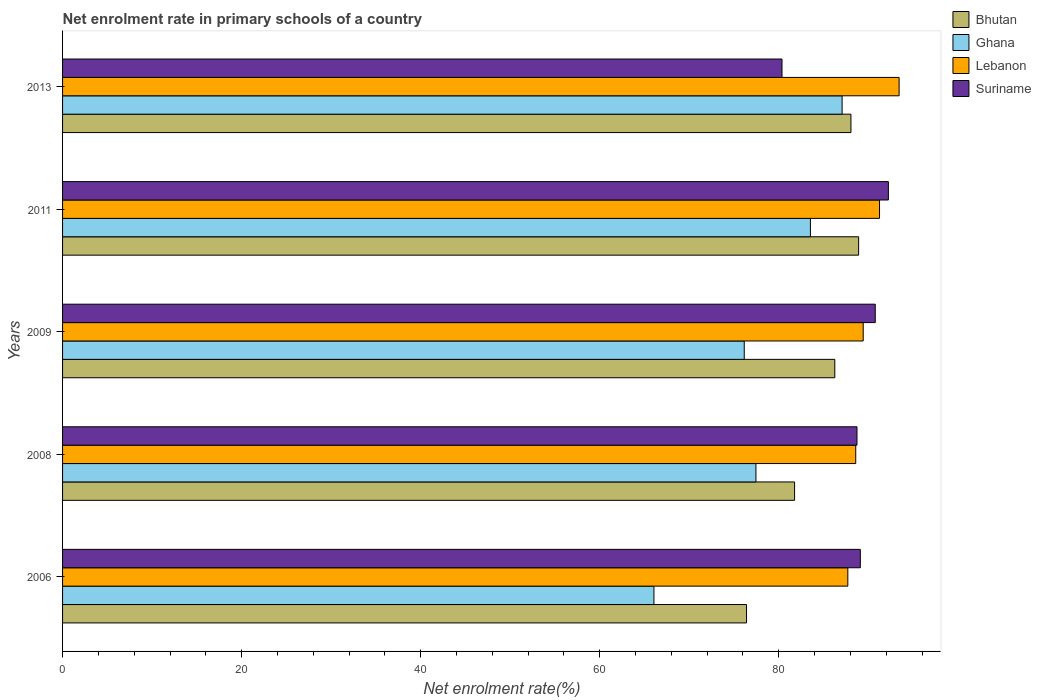How many groups of bars are there?
Give a very brief answer. 5. How many bars are there on the 4th tick from the top?
Your answer should be very brief. 4. How many bars are there on the 5th tick from the bottom?
Give a very brief answer. 4. What is the label of the 3rd group of bars from the top?
Provide a short and direct response. 2009. What is the net enrolment rate in primary schools in Bhutan in 2008?
Your answer should be compact. 81.77. Across all years, what is the maximum net enrolment rate in primary schools in Suriname?
Provide a succinct answer. 92.24. Across all years, what is the minimum net enrolment rate in primary schools in Suriname?
Keep it short and to the point. 80.36. In which year was the net enrolment rate in primary schools in Ghana maximum?
Your answer should be very brief. 2013. In which year was the net enrolment rate in primary schools in Lebanon minimum?
Your answer should be compact. 2006. What is the total net enrolment rate in primary schools in Ghana in the graph?
Your answer should be compact. 390.26. What is the difference between the net enrolment rate in primary schools in Lebanon in 2009 and that in 2011?
Ensure brevity in your answer.  -1.82. What is the difference between the net enrolment rate in primary schools in Bhutan in 2008 and the net enrolment rate in primary schools in Ghana in 2013?
Give a very brief answer. -5.31. What is the average net enrolment rate in primary schools in Lebanon per year?
Provide a succinct answer. 90.09. In the year 2008, what is the difference between the net enrolment rate in primary schools in Lebanon and net enrolment rate in primary schools in Suriname?
Offer a terse response. -0.14. In how many years, is the net enrolment rate in primary schools in Ghana greater than 76 %?
Offer a very short reply. 4. What is the ratio of the net enrolment rate in primary schools in Lebanon in 2008 to that in 2013?
Give a very brief answer. 0.95. Is the net enrolment rate in primary schools in Suriname in 2006 less than that in 2011?
Ensure brevity in your answer.  Yes. What is the difference between the highest and the second highest net enrolment rate in primary schools in Lebanon?
Give a very brief answer. 2.19. What is the difference between the highest and the lowest net enrolment rate in primary schools in Lebanon?
Keep it short and to the point. 5.73. In how many years, is the net enrolment rate in primary schools in Bhutan greater than the average net enrolment rate in primary schools in Bhutan taken over all years?
Your response must be concise. 3. Is it the case that in every year, the sum of the net enrolment rate in primary schools in Suriname and net enrolment rate in primary schools in Lebanon is greater than the sum of net enrolment rate in primary schools in Ghana and net enrolment rate in primary schools in Bhutan?
Your answer should be compact. Yes. What does the 1st bar from the top in 2006 represents?
Make the answer very short. Suriname. What does the 2nd bar from the bottom in 2011 represents?
Provide a succinct answer. Ghana. Is it the case that in every year, the sum of the net enrolment rate in primary schools in Suriname and net enrolment rate in primary schools in Ghana is greater than the net enrolment rate in primary schools in Bhutan?
Your answer should be compact. Yes. How many bars are there?
Your answer should be compact. 20. How many years are there in the graph?
Your answer should be very brief. 5. What is the difference between two consecutive major ticks on the X-axis?
Keep it short and to the point. 20. Does the graph contain any zero values?
Keep it short and to the point. No. Does the graph contain grids?
Offer a very short reply. No. Where does the legend appear in the graph?
Provide a short and direct response. Top right. How are the legend labels stacked?
Give a very brief answer. Vertical. What is the title of the graph?
Your answer should be compact. Net enrolment rate in primary schools of a country. What is the label or title of the X-axis?
Make the answer very short. Net enrolment rate(%). What is the Net enrolment rate(%) in Bhutan in 2006?
Offer a very short reply. 76.4. What is the Net enrolment rate(%) of Ghana in 2006?
Your answer should be very brief. 66.06. What is the Net enrolment rate(%) of Lebanon in 2006?
Give a very brief answer. 87.71. What is the Net enrolment rate(%) in Suriname in 2006?
Your answer should be very brief. 89.11. What is the Net enrolment rate(%) in Bhutan in 2008?
Give a very brief answer. 81.77. What is the Net enrolment rate(%) in Ghana in 2008?
Keep it short and to the point. 77.45. What is the Net enrolment rate(%) in Lebanon in 2008?
Provide a short and direct response. 88.6. What is the Net enrolment rate(%) of Suriname in 2008?
Your answer should be compact. 88.74. What is the Net enrolment rate(%) in Bhutan in 2009?
Keep it short and to the point. 86.26. What is the Net enrolment rate(%) in Ghana in 2009?
Keep it short and to the point. 76.14. What is the Net enrolment rate(%) of Lebanon in 2009?
Give a very brief answer. 89.43. What is the Net enrolment rate(%) of Suriname in 2009?
Give a very brief answer. 90.78. What is the Net enrolment rate(%) of Bhutan in 2011?
Your answer should be compact. 88.92. What is the Net enrolment rate(%) in Ghana in 2011?
Provide a succinct answer. 83.54. What is the Net enrolment rate(%) of Lebanon in 2011?
Offer a very short reply. 91.26. What is the Net enrolment rate(%) in Suriname in 2011?
Provide a succinct answer. 92.24. What is the Net enrolment rate(%) in Bhutan in 2013?
Provide a short and direct response. 88.06. What is the Net enrolment rate(%) of Ghana in 2013?
Provide a succinct answer. 87.07. What is the Net enrolment rate(%) in Lebanon in 2013?
Ensure brevity in your answer.  93.44. What is the Net enrolment rate(%) of Suriname in 2013?
Provide a short and direct response. 80.36. Across all years, what is the maximum Net enrolment rate(%) in Bhutan?
Make the answer very short. 88.92. Across all years, what is the maximum Net enrolment rate(%) of Ghana?
Provide a short and direct response. 87.07. Across all years, what is the maximum Net enrolment rate(%) of Lebanon?
Offer a very short reply. 93.44. Across all years, what is the maximum Net enrolment rate(%) in Suriname?
Give a very brief answer. 92.24. Across all years, what is the minimum Net enrolment rate(%) of Bhutan?
Give a very brief answer. 76.4. Across all years, what is the minimum Net enrolment rate(%) of Ghana?
Keep it short and to the point. 66.06. Across all years, what is the minimum Net enrolment rate(%) of Lebanon?
Offer a very short reply. 87.71. Across all years, what is the minimum Net enrolment rate(%) of Suriname?
Your answer should be very brief. 80.36. What is the total Net enrolment rate(%) of Bhutan in the graph?
Your response must be concise. 421.4. What is the total Net enrolment rate(%) of Ghana in the graph?
Your answer should be very brief. 390.26. What is the total Net enrolment rate(%) of Lebanon in the graph?
Your response must be concise. 450.44. What is the total Net enrolment rate(%) in Suriname in the graph?
Your answer should be compact. 441.23. What is the difference between the Net enrolment rate(%) of Bhutan in 2006 and that in 2008?
Offer a terse response. -5.37. What is the difference between the Net enrolment rate(%) of Ghana in 2006 and that in 2008?
Offer a terse response. -11.39. What is the difference between the Net enrolment rate(%) of Lebanon in 2006 and that in 2008?
Keep it short and to the point. -0.88. What is the difference between the Net enrolment rate(%) in Suriname in 2006 and that in 2008?
Provide a short and direct response. 0.37. What is the difference between the Net enrolment rate(%) of Bhutan in 2006 and that in 2009?
Your response must be concise. -9.86. What is the difference between the Net enrolment rate(%) of Ghana in 2006 and that in 2009?
Ensure brevity in your answer.  -10.09. What is the difference between the Net enrolment rate(%) of Lebanon in 2006 and that in 2009?
Your response must be concise. -1.72. What is the difference between the Net enrolment rate(%) of Suriname in 2006 and that in 2009?
Provide a succinct answer. -1.67. What is the difference between the Net enrolment rate(%) of Bhutan in 2006 and that in 2011?
Your response must be concise. -12.52. What is the difference between the Net enrolment rate(%) in Ghana in 2006 and that in 2011?
Provide a succinct answer. -17.48. What is the difference between the Net enrolment rate(%) of Lebanon in 2006 and that in 2011?
Offer a terse response. -3.54. What is the difference between the Net enrolment rate(%) in Suriname in 2006 and that in 2011?
Provide a succinct answer. -3.13. What is the difference between the Net enrolment rate(%) in Bhutan in 2006 and that in 2013?
Ensure brevity in your answer.  -11.66. What is the difference between the Net enrolment rate(%) in Ghana in 2006 and that in 2013?
Ensure brevity in your answer.  -21.02. What is the difference between the Net enrolment rate(%) in Lebanon in 2006 and that in 2013?
Make the answer very short. -5.73. What is the difference between the Net enrolment rate(%) of Suriname in 2006 and that in 2013?
Provide a short and direct response. 8.75. What is the difference between the Net enrolment rate(%) of Bhutan in 2008 and that in 2009?
Your answer should be compact. -4.49. What is the difference between the Net enrolment rate(%) of Ghana in 2008 and that in 2009?
Keep it short and to the point. 1.31. What is the difference between the Net enrolment rate(%) in Lebanon in 2008 and that in 2009?
Provide a short and direct response. -0.83. What is the difference between the Net enrolment rate(%) of Suriname in 2008 and that in 2009?
Your response must be concise. -2.04. What is the difference between the Net enrolment rate(%) in Bhutan in 2008 and that in 2011?
Your answer should be compact. -7.15. What is the difference between the Net enrolment rate(%) in Ghana in 2008 and that in 2011?
Your answer should be compact. -6.08. What is the difference between the Net enrolment rate(%) in Lebanon in 2008 and that in 2011?
Keep it short and to the point. -2.66. What is the difference between the Net enrolment rate(%) in Suriname in 2008 and that in 2011?
Your answer should be compact. -3.51. What is the difference between the Net enrolment rate(%) of Bhutan in 2008 and that in 2013?
Offer a very short reply. -6.29. What is the difference between the Net enrolment rate(%) of Ghana in 2008 and that in 2013?
Your response must be concise. -9.62. What is the difference between the Net enrolment rate(%) in Lebanon in 2008 and that in 2013?
Your answer should be compact. -4.84. What is the difference between the Net enrolment rate(%) of Suriname in 2008 and that in 2013?
Make the answer very short. 8.38. What is the difference between the Net enrolment rate(%) of Bhutan in 2009 and that in 2011?
Your answer should be very brief. -2.66. What is the difference between the Net enrolment rate(%) in Ghana in 2009 and that in 2011?
Your answer should be very brief. -7.39. What is the difference between the Net enrolment rate(%) in Lebanon in 2009 and that in 2011?
Your answer should be compact. -1.82. What is the difference between the Net enrolment rate(%) of Suriname in 2009 and that in 2011?
Offer a terse response. -1.47. What is the difference between the Net enrolment rate(%) of Bhutan in 2009 and that in 2013?
Make the answer very short. -1.8. What is the difference between the Net enrolment rate(%) of Ghana in 2009 and that in 2013?
Offer a very short reply. -10.93. What is the difference between the Net enrolment rate(%) of Lebanon in 2009 and that in 2013?
Give a very brief answer. -4.01. What is the difference between the Net enrolment rate(%) of Suriname in 2009 and that in 2013?
Your answer should be very brief. 10.42. What is the difference between the Net enrolment rate(%) of Bhutan in 2011 and that in 2013?
Your answer should be compact. 0.86. What is the difference between the Net enrolment rate(%) in Ghana in 2011 and that in 2013?
Offer a terse response. -3.54. What is the difference between the Net enrolment rate(%) of Lebanon in 2011 and that in 2013?
Give a very brief answer. -2.19. What is the difference between the Net enrolment rate(%) of Suriname in 2011 and that in 2013?
Make the answer very short. 11.88. What is the difference between the Net enrolment rate(%) in Bhutan in 2006 and the Net enrolment rate(%) in Ghana in 2008?
Offer a very short reply. -1.05. What is the difference between the Net enrolment rate(%) of Bhutan in 2006 and the Net enrolment rate(%) of Lebanon in 2008?
Your answer should be compact. -12.2. What is the difference between the Net enrolment rate(%) in Bhutan in 2006 and the Net enrolment rate(%) in Suriname in 2008?
Keep it short and to the point. -12.34. What is the difference between the Net enrolment rate(%) of Ghana in 2006 and the Net enrolment rate(%) of Lebanon in 2008?
Keep it short and to the point. -22.54. What is the difference between the Net enrolment rate(%) in Ghana in 2006 and the Net enrolment rate(%) in Suriname in 2008?
Ensure brevity in your answer.  -22.68. What is the difference between the Net enrolment rate(%) of Lebanon in 2006 and the Net enrolment rate(%) of Suriname in 2008?
Provide a succinct answer. -1.02. What is the difference between the Net enrolment rate(%) in Bhutan in 2006 and the Net enrolment rate(%) in Ghana in 2009?
Offer a very short reply. 0.25. What is the difference between the Net enrolment rate(%) of Bhutan in 2006 and the Net enrolment rate(%) of Lebanon in 2009?
Your response must be concise. -13.03. What is the difference between the Net enrolment rate(%) of Bhutan in 2006 and the Net enrolment rate(%) of Suriname in 2009?
Ensure brevity in your answer.  -14.38. What is the difference between the Net enrolment rate(%) of Ghana in 2006 and the Net enrolment rate(%) of Lebanon in 2009?
Your answer should be compact. -23.38. What is the difference between the Net enrolment rate(%) of Ghana in 2006 and the Net enrolment rate(%) of Suriname in 2009?
Keep it short and to the point. -24.72. What is the difference between the Net enrolment rate(%) in Lebanon in 2006 and the Net enrolment rate(%) in Suriname in 2009?
Your answer should be very brief. -3.06. What is the difference between the Net enrolment rate(%) of Bhutan in 2006 and the Net enrolment rate(%) of Ghana in 2011?
Your answer should be compact. -7.14. What is the difference between the Net enrolment rate(%) of Bhutan in 2006 and the Net enrolment rate(%) of Lebanon in 2011?
Keep it short and to the point. -14.86. What is the difference between the Net enrolment rate(%) of Bhutan in 2006 and the Net enrolment rate(%) of Suriname in 2011?
Give a very brief answer. -15.85. What is the difference between the Net enrolment rate(%) of Ghana in 2006 and the Net enrolment rate(%) of Lebanon in 2011?
Give a very brief answer. -25.2. What is the difference between the Net enrolment rate(%) of Ghana in 2006 and the Net enrolment rate(%) of Suriname in 2011?
Your response must be concise. -26.19. What is the difference between the Net enrolment rate(%) in Lebanon in 2006 and the Net enrolment rate(%) in Suriname in 2011?
Ensure brevity in your answer.  -4.53. What is the difference between the Net enrolment rate(%) of Bhutan in 2006 and the Net enrolment rate(%) of Ghana in 2013?
Your answer should be compact. -10.68. What is the difference between the Net enrolment rate(%) of Bhutan in 2006 and the Net enrolment rate(%) of Lebanon in 2013?
Give a very brief answer. -17.04. What is the difference between the Net enrolment rate(%) in Bhutan in 2006 and the Net enrolment rate(%) in Suriname in 2013?
Your answer should be very brief. -3.96. What is the difference between the Net enrolment rate(%) of Ghana in 2006 and the Net enrolment rate(%) of Lebanon in 2013?
Make the answer very short. -27.39. What is the difference between the Net enrolment rate(%) in Ghana in 2006 and the Net enrolment rate(%) in Suriname in 2013?
Give a very brief answer. -14.31. What is the difference between the Net enrolment rate(%) in Lebanon in 2006 and the Net enrolment rate(%) in Suriname in 2013?
Keep it short and to the point. 7.35. What is the difference between the Net enrolment rate(%) in Bhutan in 2008 and the Net enrolment rate(%) in Ghana in 2009?
Offer a very short reply. 5.62. What is the difference between the Net enrolment rate(%) of Bhutan in 2008 and the Net enrolment rate(%) of Lebanon in 2009?
Your response must be concise. -7.67. What is the difference between the Net enrolment rate(%) in Bhutan in 2008 and the Net enrolment rate(%) in Suriname in 2009?
Offer a very short reply. -9.01. What is the difference between the Net enrolment rate(%) of Ghana in 2008 and the Net enrolment rate(%) of Lebanon in 2009?
Provide a short and direct response. -11.98. What is the difference between the Net enrolment rate(%) of Ghana in 2008 and the Net enrolment rate(%) of Suriname in 2009?
Keep it short and to the point. -13.33. What is the difference between the Net enrolment rate(%) in Lebanon in 2008 and the Net enrolment rate(%) in Suriname in 2009?
Ensure brevity in your answer.  -2.18. What is the difference between the Net enrolment rate(%) in Bhutan in 2008 and the Net enrolment rate(%) in Ghana in 2011?
Provide a succinct answer. -1.77. What is the difference between the Net enrolment rate(%) in Bhutan in 2008 and the Net enrolment rate(%) in Lebanon in 2011?
Keep it short and to the point. -9.49. What is the difference between the Net enrolment rate(%) in Bhutan in 2008 and the Net enrolment rate(%) in Suriname in 2011?
Provide a succinct answer. -10.48. What is the difference between the Net enrolment rate(%) of Ghana in 2008 and the Net enrolment rate(%) of Lebanon in 2011?
Ensure brevity in your answer.  -13.81. What is the difference between the Net enrolment rate(%) in Ghana in 2008 and the Net enrolment rate(%) in Suriname in 2011?
Your answer should be very brief. -14.79. What is the difference between the Net enrolment rate(%) in Lebanon in 2008 and the Net enrolment rate(%) in Suriname in 2011?
Ensure brevity in your answer.  -3.65. What is the difference between the Net enrolment rate(%) of Bhutan in 2008 and the Net enrolment rate(%) of Ghana in 2013?
Offer a terse response. -5.31. What is the difference between the Net enrolment rate(%) in Bhutan in 2008 and the Net enrolment rate(%) in Lebanon in 2013?
Provide a short and direct response. -11.68. What is the difference between the Net enrolment rate(%) in Bhutan in 2008 and the Net enrolment rate(%) in Suriname in 2013?
Provide a succinct answer. 1.4. What is the difference between the Net enrolment rate(%) of Ghana in 2008 and the Net enrolment rate(%) of Lebanon in 2013?
Give a very brief answer. -15.99. What is the difference between the Net enrolment rate(%) of Ghana in 2008 and the Net enrolment rate(%) of Suriname in 2013?
Your answer should be very brief. -2.91. What is the difference between the Net enrolment rate(%) of Lebanon in 2008 and the Net enrolment rate(%) of Suriname in 2013?
Ensure brevity in your answer.  8.24. What is the difference between the Net enrolment rate(%) in Bhutan in 2009 and the Net enrolment rate(%) in Ghana in 2011?
Make the answer very short. 2.72. What is the difference between the Net enrolment rate(%) in Bhutan in 2009 and the Net enrolment rate(%) in Lebanon in 2011?
Give a very brief answer. -5. What is the difference between the Net enrolment rate(%) of Bhutan in 2009 and the Net enrolment rate(%) of Suriname in 2011?
Your response must be concise. -5.99. What is the difference between the Net enrolment rate(%) of Ghana in 2009 and the Net enrolment rate(%) of Lebanon in 2011?
Your answer should be compact. -15.11. What is the difference between the Net enrolment rate(%) in Ghana in 2009 and the Net enrolment rate(%) in Suriname in 2011?
Your answer should be compact. -16.1. What is the difference between the Net enrolment rate(%) of Lebanon in 2009 and the Net enrolment rate(%) of Suriname in 2011?
Make the answer very short. -2.81. What is the difference between the Net enrolment rate(%) of Bhutan in 2009 and the Net enrolment rate(%) of Ghana in 2013?
Your response must be concise. -0.82. What is the difference between the Net enrolment rate(%) of Bhutan in 2009 and the Net enrolment rate(%) of Lebanon in 2013?
Provide a short and direct response. -7.18. What is the difference between the Net enrolment rate(%) in Bhutan in 2009 and the Net enrolment rate(%) in Suriname in 2013?
Keep it short and to the point. 5.9. What is the difference between the Net enrolment rate(%) in Ghana in 2009 and the Net enrolment rate(%) in Lebanon in 2013?
Make the answer very short. -17.3. What is the difference between the Net enrolment rate(%) of Ghana in 2009 and the Net enrolment rate(%) of Suriname in 2013?
Offer a very short reply. -4.22. What is the difference between the Net enrolment rate(%) of Lebanon in 2009 and the Net enrolment rate(%) of Suriname in 2013?
Offer a very short reply. 9.07. What is the difference between the Net enrolment rate(%) of Bhutan in 2011 and the Net enrolment rate(%) of Ghana in 2013?
Your answer should be compact. 1.85. What is the difference between the Net enrolment rate(%) of Bhutan in 2011 and the Net enrolment rate(%) of Lebanon in 2013?
Ensure brevity in your answer.  -4.52. What is the difference between the Net enrolment rate(%) in Bhutan in 2011 and the Net enrolment rate(%) in Suriname in 2013?
Provide a short and direct response. 8.56. What is the difference between the Net enrolment rate(%) of Ghana in 2011 and the Net enrolment rate(%) of Lebanon in 2013?
Keep it short and to the point. -9.91. What is the difference between the Net enrolment rate(%) of Ghana in 2011 and the Net enrolment rate(%) of Suriname in 2013?
Provide a succinct answer. 3.17. What is the difference between the Net enrolment rate(%) of Lebanon in 2011 and the Net enrolment rate(%) of Suriname in 2013?
Make the answer very short. 10.89. What is the average Net enrolment rate(%) of Bhutan per year?
Offer a very short reply. 84.28. What is the average Net enrolment rate(%) in Ghana per year?
Offer a terse response. 78.05. What is the average Net enrolment rate(%) of Lebanon per year?
Make the answer very short. 90.09. What is the average Net enrolment rate(%) in Suriname per year?
Your answer should be compact. 88.25. In the year 2006, what is the difference between the Net enrolment rate(%) of Bhutan and Net enrolment rate(%) of Ghana?
Your answer should be compact. 10.34. In the year 2006, what is the difference between the Net enrolment rate(%) in Bhutan and Net enrolment rate(%) in Lebanon?
Provide a short and direct response. -11.32. In the year 2006, what is the difference between the Net enrolment rate(%) in Bhutan and Net enrolment rate(%) in Suriname?
Offer a terse response. -12.71. In the year 2006, what is the difference between the Net enrolment rate(%) in Ghana and Net enrolment rate(%) in Lebanon?
Your response must be concise. -21.66. In the year 2006, what is the difference between the Net enrolment rate(%) in Ghana and Net enrolment rate(%) in Suriname?
Provide a short and direct response. -23.06. In the year 2006, what is the difference between the Net enrolment rate(%) in Lebanon and Net enrolment rate(%) in Suriname?
Your response must be concise. -1.4. In the year 2008, what is the difference between the Net enrolment rate(%) of Bhutan and Net enrolment rate(%) of Ghana?
Ensure brevity in your answer.  4.32. In the year 2008, what is the difference between the Net enrolment rate(%) of Bhutan and Net enrolment rate(%) of Lebanon?
Your answer should be very brief. -6.83. In the year 2008, what is the difference between the Net enrolment rate(%) in Bhutan and Net enrolment rate(%) in Suriname?
Offer a very short reply. -6.97. In the year 2008, what is the difference between the Net enrolment rate(%) in Ghana and Net enrolment rate(%) in Lebanon?
Offer a very short reply. -11.15. In the year 2008, what is the difference between the Net enrolment rate(%) of Ghana and Net enrolment rate(%) of Suriname?
Provide a succinct answer. -11.29. In the year 2008, what is the difference between the Net enrolment rate(%) in Lebanon and Net enrolment rate(%) in Suriname?
Ensure brevity in your answer.  -0.14. In the year 2009, what is the difference between the Net enrolment rate(%) of Bhutan and Net enrolment rate(%) of Ghana?
Your response must be concise. 10.11. In the year 2009, what is the difference between the Net enrolment rate(%) of Bhutan and Net enrolment rate(%) of Lebanon?
Give a very brief answer. -3.17. In the year 2009, what is the difference between the Net enrolment rate(%) in Bhutan and Net enrolment rate(%) in Suriname?
Your answer should be very brief. -4.52. In the year 2009, what is the difference between the Net enrolment rate(%) in Ghana and Net enrolment rate(%) in Lebanon?
Provide a short and direct response. -13.29. In the year 2009, what is the difference between the Net enrolment rate(%) of Ghana and Net enrolment rate(%) of Suriname?
Make the answer very short. -14.63. In the year 2009, what is the difference between the Net enrolment rate(%) in Lebanon and Net enrolment rate(%) in Suriname?
Keep it short and to the point. -1.35. In the year 2011, what is the difference between the Net enrolment rate(%) in Bhutan and Net enrolment rate(%) in Ghana?
Your response must be concise. 5.38. In the year 2011, what is the difference between the Net enrolment rate(%) of Bhutan and Net enrolment rate(%) of Lebanon?
Offer a very short reply. -2.34. In the year 2011, what is the difference between the Net enrolment rate(%) in Bhutan and Net enrolment rate(%) in Suriname?
Your answer should be very brief. -3.32. In the year 2011, what is the difference between the Net enrolment rate(%) in Ghana and Net enrolment rate(%) in Lebanon?
Provide a succinct answer. -7.72. In the year 2011, what is the difference between the Net enrolment rate(%) in Ghana and Net enrolment rate(%) in Suriname?
Provide a short and direct response. -8.71. In the year 2011, what is the difference between the Net enrolment rate(%) in Lebanon and Net enrolment rate(%) in Suriname?
Make the answer very short. -0.99. In the year 2013, what is the difference between the Net enrolment rate(%) in Bhutan and Net enrolment rate(%) in Ghana?
Provide a succinct answer. 0.99. In the year 2013, what is the difference between the Net enrolment rate(%) of Bhutan and Net enrolment rate(%) of Lebanon?
Your answer should be compact. -5.38. In the year 2013, what is the difference between the Net enrolment rate(%) of Bhutan and Net enrolment rate(%) of Suriname?
Your answer should be compact. 7.7. In the year 2013, what is the difference between the Net enrolment rate(%) in Ghana and Net enrolment rate(%) in Lebanon?
Your answer should be very brief. -6.37. In the year 2013, what is the difference between the Net enrolment rate(%) in Ghana and Net enrolment rate(%) in Suriname?
Your answer should be compact. 6.71. In the year 2013, what is the difference between the Net enrolment rate(%) in Lebanon and Net enrolment rate(%) in Suriname?
Offer a terse response. 13.08. What is the ratio of the Net enrolment rate(%) of Bhutan in 2006 to that in 2008?
Your answer should be very brief. 0.93. What is the ratio of the Net enrolment rate(%) of Ghana in 2006 to that in 2008?
Keep it short and to the point. 0.85. What is the ratio of the Net enrolment rate(%) in Lebanon in 2006 to that in 2008?
Offer a very short reply. 0.99. What is the ratio of the Net enrolment rate(%) in Suriname in 2006 to that in 2008?
Your answer should be compact. 1. What is the ratio of the Net enrolment rate(%) of Bhutan in 2006 to that in 2009?
Your answer should be very brief. 0.89. What is the ratio of the Net enrolment rate(%) in Ghana in 2006 to that in 2009?
Your response must be concise. 0.87. What is the ratio of the Net enrolment rate(%) of Lebanon in 2006 to that in 2009?
Provide a succinct answer. 0.98. What is the ratio of the Net enrolment rate(%) of Suriname in 2006 to that in 2009?
Offer a terse response. 0.98. What is the ratio of the Net enrolment rate(%) in Bhutan in 2006 to that in 2011?
Your answer should be very brief. 0.86. What is the ratio of the Net enrolment rate(%) of Ghana in 2006 to that in 2011?
Provide a succinct answer. 0.79. What is the ratio of the Net enrolment rate(%) of Lebanon in 2006 to that in 2011?
Provide a succinct answer. 0.96. What is the ratio of the Net enrolment rate(%) in Suriname in 2006 to that in 2011?
Offer a very short reply. 0.97. What is the ratio of the Net enrolment rate(%) in Bhutan in 2006 to that in 2013?
Offer a terse response. 0.87. What is the ratio of the Net enrolment rate(%) in Ghana in 2006 to that in 2013?
Your answer should be compact. 0.76. What is the ratio of the Net enrolment rate(%) in Lebanon in 2006 to that in 2013?
Ensure brevity in your answer.  0.94. What is the ratio of the Net enrolment rate(%) in Suriname in 2006 to that in 2013?
Provide a succinct answer. 1.11. What is the ratio of the Net enrolment rate(%) of Bhutan in 2008 to that in 2009?
Keep it short and to the point. 0.95. What is the ratio of the Net enrolment rate(%) of Ghana in 2008 to that in 2009?
Your answer should be very brief. 1.02. What is the ratio of the Net enrolment rate(%) in Lebanon in 2008 to that in 2009?
Your answer should be compact. 0.99. What is the ratio of the Net enrolment rate(%) of Suriname in 2008 to that in 2009?
Make the answer very short. 0.98. What is the ratio of the Net enrolment rate(%) of Bhutan in 2008 to that in 2011?
Offer a terse response. 0.92. What is the ratio of the Net enrolment rate(%) in Ghana in 2008 to that in 2011?
Your answer should be compact. 0.93. What is the ratio of the Net enrolment rate(%) in Lebanon in 2008 to that in 2011?
Provide a short and direct response. 0.97. What is the ratio of the Net enrolment rate(%) in Suriname in 2008 to that in 2011?
Make the answer very short. 0.96. What is the ratio of the Net enrolment rate(%) of Bhutan in 2008 to that in 2013?
Keep it short and to the point. 0.93. What is the ratio of the Net enrolment rate(%) in Ghana in 2008 to that in 2013?
Make the answer very short. 0.89. What is the ratio of the Net enrolment rate(%) in Lebanon in 2008 to that in 2013?
Give a very brief answer. 0.95. What is the ratio of the Net enrolment rate(%) of Suriname in 2008 to that in 2013?
Your response must be concise. 1.1. What is the ratio of the Net enrolment rate(%) in Bhutan in 2009 to that in 2011?
Give a very brief answer. 0.97. What is the ratio of the Net enrolment rate(%) in Ghana in 2009 to that in 2011?
Provide a short and direct response. 0.91. What is the ratio of the Net enrolment rate(%) in Suriname in 2009 to that in 2011?
Your answer should be compact. 0.98. What is the ratio of the Net enrolment rate(%) in Bhutan in 2009 to that in 2013?
Ensure brevity in your answer.  0.98. What is the ratio of the Net enrolment rate(%) in Ghana in 2009 to that in 2013?
Ensure brevity in your answer.  0.87. What is the ratio of the Net enrolment rate(%) of Lebanon in 2009 to that in 2013?
Your response must be concise. 0.96. What is the ratio of the Net enrolment rate(%) of Suriname in 2009 to that in 2013?
Your answer should be compact. 1.13. What is the ratio of the Net enrolment rate(%) in Bhutan in 2011 to that in 2013?
Keep it short and to the point. 1.01. What is the ratio of the Net enrolment rate(%) in Ghana in 2011 to that in 2013?
Your answer should be very brief. 0.96. What is the ratio of the Net enrolment rate(%) of Lebanon in 2011 to that in 2013?
Your response must be concise. 0.98. What is the ratio of the Net enrolment rate(%) of Suriname in 2011 to that in 2013?
Offer a terse response. 1.15. What is the difference between the highest and the second highest Net enrolment rate(%) in Bhutan?
Provide a succinct answer. 0.86. What is the difference between the highest and the second highest Net enrolment rate(%) of Ghana?
Keep it short and to the point. 3.54. What is the difference between the highest and the second highest Net enrolment rate(%) in Lebanon?
Keep it short and to the point. 2.19. What is the difference between the highest and the second highest Net enrolment rate(%) in Suriname?
Ensure brevity in your answer.  1.47. What is the difference between the highest and the lowest Net enrolment rate(%) in Bhutan?
Keep it short and to the point. 12.52. What is the difference between the highest and the lowest Net enrolment rate(%) in Ghana?
Give a very brief answer. 21.02. What is the difference between the highest and the lowest Net enrolment rate(%) of Lebanon?
Your answer should be compact. 5.73. What is the difference between the highest and the lowest Net enrolment rate(%) in Suriname?
Ensure brevity in your answer.  11.88. 